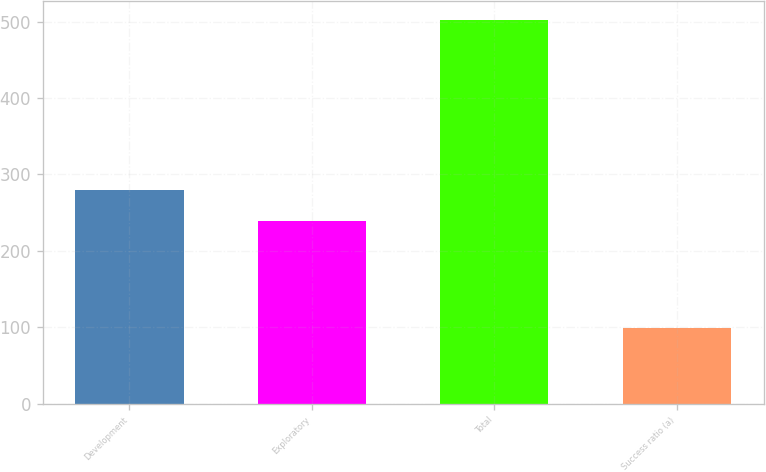Convert chart. <chart><loc_0><loc_0><loc_500><loc_500><bar_chart><fcel>Development<fcel>Exploratory<fcel>Total<fcel>Success ratio (a)<nl><fcel>279.3<fcel>239<fcel>502<fcel>99<nl></chart> 